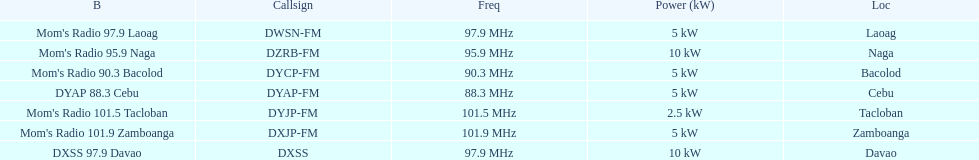How many stations broadcast with a power of 5kw? 4. 